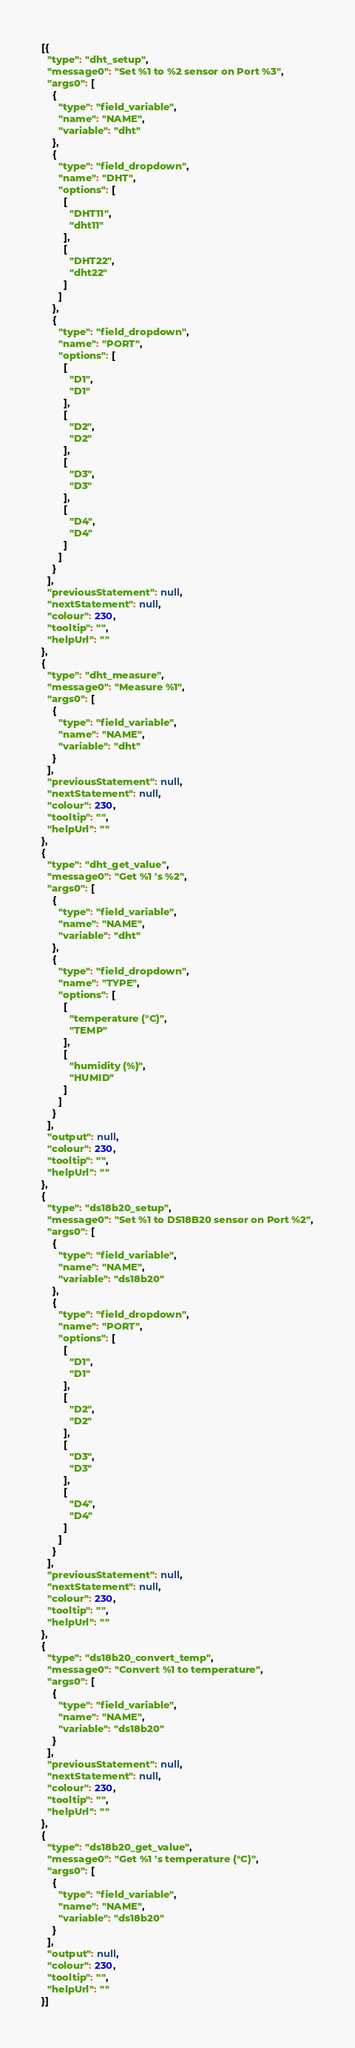Convert code to text. <code><loc_0><loc_0><loc_500><loc_500><_JavaScript_>[{
  "type": "dht_setup",
  "message0": "Set %1 to %2 sensor on Port %3",
  "args0": [
    {
      "type": "field_variable",
      "name": "NAME",
      "variable": "dht"
    },
    {
      "type": "field_dropdown",
      "name": "DHT",
      "options": [
        [
          "DHT11",
          "dht11"
        ],
        [
          "DHT22",
          "dht22"
        ]
      ]
    },
    {
      "type": "field_dropdown",
      "name": "PORT",
      "options": [
        [
          "D1",
          "D1"
        ],
        [
          "D2",
          "D2"
        ],
        [
          "D3",
          "D3"
        ],
        [
          "D4",
          "D4"
        ]
      ]
    }
  ],
  "previousStatement": null,
  "nextStatement": null,
  "colour": 230,
  "tooltip": "",
  "helpUrl": ""
},
{
  "type": "dht_measure",
  "message0": "Measure %1",
  "args0": [
    {
      "type": "field_variable",
      "name": "NAME",
      "variable": "dht"
    }
  ],
  "previousStatement": null,
  "nextStatement": null,
  "colour": 230,
  "tooltip": "",
  "helpUrl": ""
},
{
  "type": "dht_get_value",
  "message0": "Get %1 's %2",
  "args0": [
    {
      "type": "field_variable",
      "name": "NAME",
      "variable": "dht"
    },
    {
      "type": "field_dropdown",
      "name": "TYPE",
      "options": [
        [
          "temperature (°C)",
          "TEMP"
        ],
        [
          "humidity (%)",
          "HUMID"
        ]
      ]
    }
  ],
  "output": null,
  "colour": 230,
  "tooltip": "",
  "helpUrl": ""
},
{
  "type": "ds18b20_setup",
  "message0": "Set %1 to DS18B20 sensor on Port %2",
  "args0": [
    {
      "type": "field_variable",
      "name": "NAME",
      "variable": "ds18b20"
    },
    {
      "type": "field_dropdown",
      "name": "PORT",
      "options": [
        [
          "D1",
          "D1"
        ],
        [
          "D2",
          "D2"
        ],
        [
          "D3",
          "D3"
        ],
        [
          "D4",
          "D4"
        ]
      ]
    }
  ],
  "previousStatement": null,
  "nextStatement": null,
  "colour": 230,
  "tooltip": "",
  "helpUrl": ""
},
{
  "type": "ds18b20_convert_temp",
  "message0": "Convert %1 to temperature",
  "args0": [
    {
      "type": "field_variable",
      "name": "NAME",
      "variable": "ds18b20"
    }
  ],
  "previousStatement": null,
  "nextStatement": null,
  "colour": 230,
  "tooltip": "",
  "helpUrl": ""
},
{
  "type": "ds18b20_get_value",
  "message0": "Get %1 's temperature (°C)",
  "args0": [
    {
      "type": "field_variable",
      "name": "NAME",
      "variable": "ds18b20"
    }
  ],
  "output": null,
  "colour": 230,
  "tooltip": "",
  "helpUrl": ""
}]</code> 